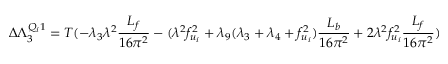Convert formula to latex. <formula><loc_0><loc_0><loc_500><loc_500>\Delta \Lambda _ { 3 } ^ { Q _ { i } 1 } = T ( - \lambda _ { 3 } \lambda ^ { 2 } { \frac { L _ { f } } { 1 6 \pi ^ { 2 } } } - ( \lambda ^ { 2 } f _ { u _ { i } } ^ { 2 } + \lambda _ { 9 } ( \lambda _ { 3 } + \lambda _ { 4 } + f _ { u _ { i } } ^ { 2 } ) { \frac { L _ { b } } { 1 6 \pi ^ { 2 } } } + 2 \lambda ^ { 2 } f _ { u _ { i } } ^ { 2 } { \frac { L _ { f } } { 1 6 \pi ^ { 2 } } } )</formula> 